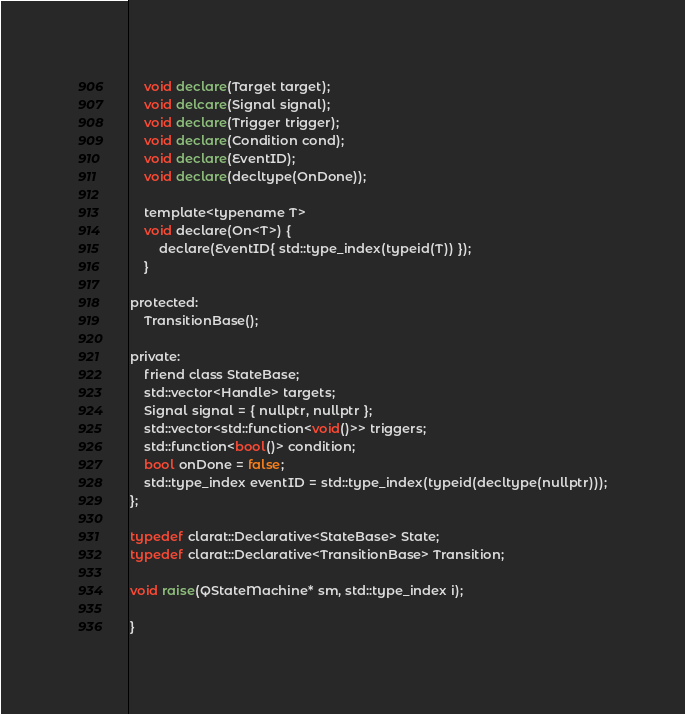<code> <loc_0><loc_0><loc_500><loc_500><_C_>    void declare(Target target);
    void delcare(Signal signal);
    void declare(Trigger trigger);
    void declare(Condition cond);
    void declare(EventID);
    void declare(decltype(OnDone));

    template<typename T>
    void declare(On<T>) {
        declare(EventID{ std::type_index(typeid(T)) });
    }

protected:
    TransitionBase();

private:
    friend class StateBase;
    std::vector<Handle> targets;
    Signal signal = { nullptr, nullptr };
    std::vector<std::function<void()>> triggers;
    std::function<bool()> condition;
    bool onDone = false;
    std::type_index eventID = std::type_index(typeid(decltype(nullptr)));
};

typedef clarat::Declarative<StateBase> State;
typedef clarat::Declarative<TransitionBase> Transition;

void raise(QStateMachine* sm, std::type_index i);

}
</code> 